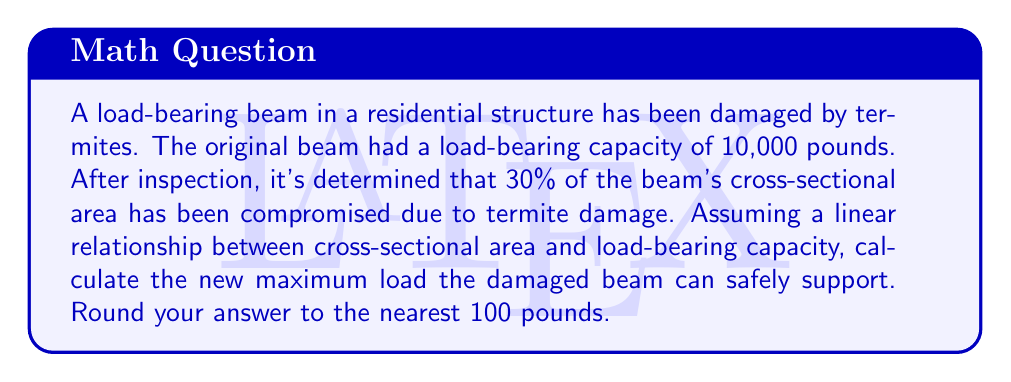Provide a solution to this math problem. To solve this problem, we need to follow these steps:

1. Understand the relationship between cross-sectional area and load-bearing capacity:
   We're told that there's a linear relationship, which means that the reduction in load-bearing capacity is proportional to the reduction in cross-sectional area.

2. Calculate the percentage of the beam's capacity that remains:
   If 30% of the beam is damaged, then 70% of the beam remains intact.
   Remaining capacity = 100% - 30% = 70%

3. Calculate the new load-bearing capacity:
   Let $L$ be the new load-bearing capacity.
   $$L = \text{Original Capacity} \times \text{Remaining Percentage}$$
   $$L = 10,000 \text{ lbs} \times 0.70$$
   $$L = 7,000 \text{ lbs}$$

4. Round to the nearest 100 pounds:
   7,000 lbs is already rounded to the nearest 100 pounds, so no further rounding is necessary.

Therefore, the new maximum load the damaged beam can safely support is 7,000 pounds.
Answer: 7,000 pounds 